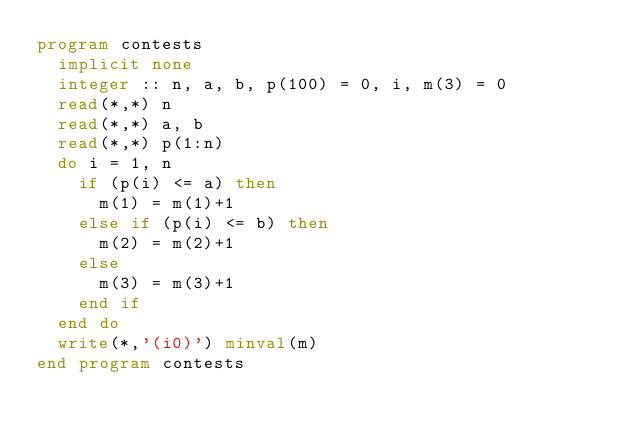<code> <loc_0><loc_0><loc_500><loc_500><_FORTRAN_>program contests
  implicit none
  integer :: n, a, b, p(100) = 0, i, m(3) = 0
  read(*,*) n
  read(*,*) a, b
  read(*,*) p(1:n)
  do i = 1, n
    if (p(i) <= a) then
      m(1) = m(1)+1
    else if (p(i) <= b) then
      m(2) = m(2)+1
    else
      m(3) = m(3)+1
    end if
  end do
  write(*,'(i0)') minval(m)
end program contests</code> 